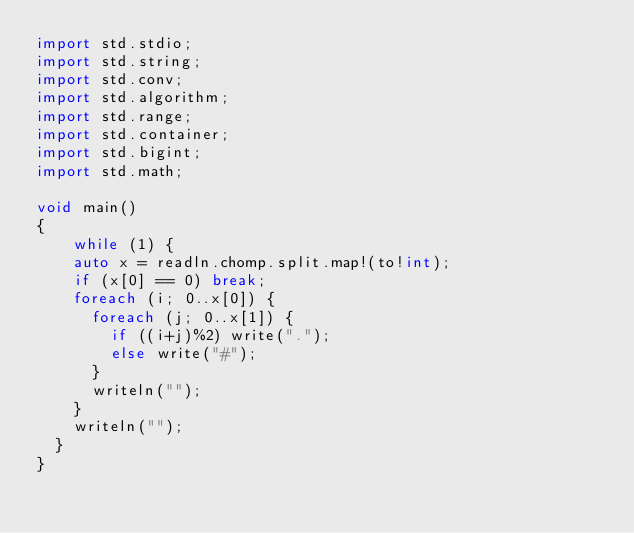<code> <loc_0><loc_0><loc_500><loc_500><_D_>import std.stdio;
import std.string;
import std.conv;
import std.algorithm;
import std.range;
import std.container;
import std.bigint;
import std.math;

void main()
{
	while (1) {
    auto x = readln.chomp.split.map!(to!int);
    if (x[0] == 0) break;
    foreach (i; 0..x[0]) {
      foreach (j; 0..x[1]) {
        if ((i+j)%2) write(".");
        else write("#");
      }
      writeln("");
    }
    writeln("");
  }
}</code> 